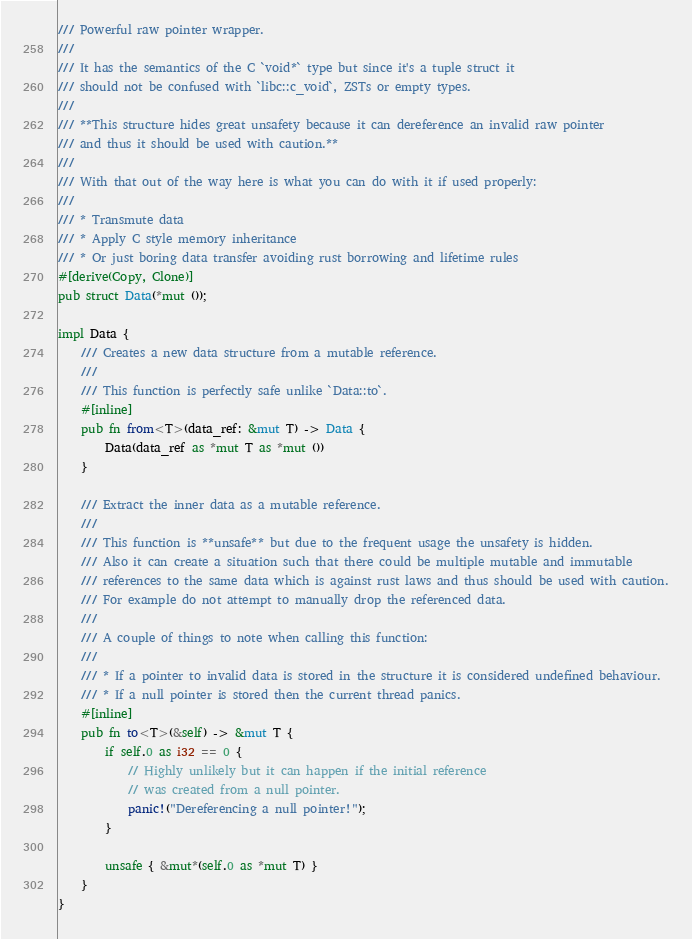<code> <loc_0><loc_0><loc_500><loc_500><_Rust_>/// Powerful raw pointer wrapper.
///
/// It has the semantics of the C `void*` type but since it's a tuple struct it
/// should not be confused with `libc::c_void`, ZSTs or empty types.
///
/// **This structure hides great unsafety because it can dereference an invalid raw pointer
/// and thus it should be used with caution.**
///
/// With that out of the way here is what you can do with it if used properly:
///
/// * Transmute data
/// * Apply C style memory inheritance
/// * Or just boring data transfer avoiding rust borrowing and lifetime rules
#[derive(Copy, Clone)]
pub struct Data(*mut ());

impl Data {
    /// Creates a new data structure from a mutable reference.
    ///
    /// This function is perfectly safe unlike `Data::to`.
    #[inline]
    pub fn from<T>(data_ref: &mut T) -> Data {
        Data(data_ref as *mut T as *mut ())
    }

    /// Extract the inner data as a mutable reference.
    ///
    /// This function is **unsafe** but due to the frequent usage the unsafety is hidden.
    /// Also it can create a situation such that there could be multiple mutable and immutable
    /// references to the same data which is against rust laws and thus should be used with caution.
    /// For example do not attempt to manually drop the referenced data.
    ///
    /// A couple of things to note when calling this function:
    ///
    /// * If a pointer to invalid data is stored in the structure it is considered undefined behaviour.
    /// * If a null pointer is stored then the current thread panics.
    #[inline]
    pub fn to<T>(&self) -> &mut T {
        if self.0 as i32 == 0 {
            // Highly unlikely but it can happen if the initial reference
            // was created from a null pointer.
            panic!("Dereferencing a null pointer!");
        }

        unsafe { &mut*(self.0 as *mut T) }
    }
}
</code> 